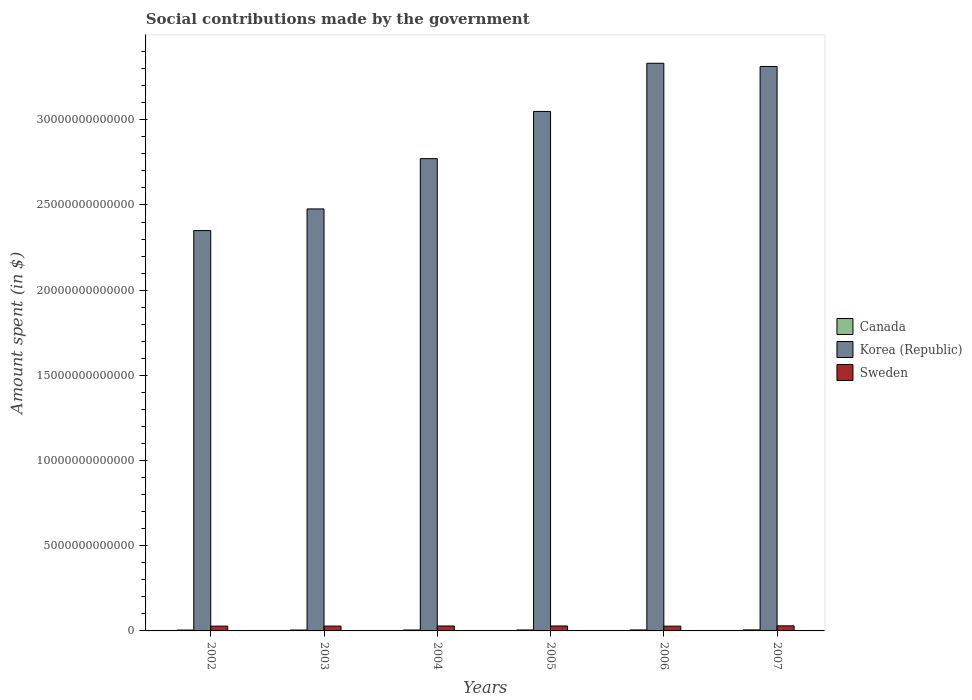How many different coloured bars are there?
Make the answer very short. 3. How many groups of bars are there?
Offer a terse response. 6. Are the number of bars on each tick of the X-axis equal?
Your answer should be compact. Yes. What is the label of the 2nd group of bars from the left?
Your response must be concise. 2003. In how many cases, is the number of bars for a given year not equal to the number of legend labels?
Your response must be concise. 0. What is the amount spent on social contributions in Sweden in 2002?
Your answer should be very brief. 2.82e+11. Across all years, what is the maximum amount spent on social contributions in Canada?
Provide a succinct answer. 6.01e+1. Across all years, what is the minimum amount spent on social contributions in Canada?
Keep it short and to the point. 5.07e+1. What is the total amount spent on social contributions in Sweden in the graph?
Ensure brevity in your answer.  1.72e+12. What is the difference between the amount spent on social contributions in Canada in 2002 and that in 2005?
Your answer should be compact. -5.92e+09. What is the difference between the amount spent on social contributions in Korea (Republic) in 2007 and the amount spent on social contributions in Sweden in 2006?
Offer a terse response. 3.29e+13. What is the average amount spent on social contributions in Korea (Republic) per year?
Provide a short and direct response. 2.88e+13. In the year 2006, what is the difference between the amount spent on social contributions in Korea (Republic) and amount spent on social contributions in Sweden?
Offer a terse response. 3.30e+13. In how many years, is the amount spent on social contributions in Canada greater than 8000000000000 $?
Your response must be concise. 0. What is the ratio of the amount spent on social contributions in Sweden in 2003 to that in 2007?
Provide a short and direct response. 0.95. What is the difference between the highest and the second highest amount spent on social contributions in Sweden?
Ensure brevity in your answer.  7.53e+09. What is the difference between the highest and the lowest amount spent on social contributions in Canada?
Ensure brevity in your answer.  9.34e+09. In how many years, is the amount spent on social contributions in Sweden greater than the average amount spent on social contributions in Sweden taken over all years?
Offer a terse response. 3. Is the sum of the amount spent on social contributions in Korea (Republic) in 2003 and 2007 greater than the maximum amount spent on social contributions in Sweden across all years?
Provide a succinct answer. Yes. What does the 2nd bar from the left in 2004 represents?
Your response must be concise. Korea (Republic). What does the 3rd bar from the right in 2007 represents?
Your response must be concise. Canada. Is it the case that in every year, the sum of the amount spent on social contributions in Sweden and amount spent on social contributions in Canada is greater than the amount spent on social contributions in Korea (Republic)?
Make the answer very short. No. How many bars are there?
Offer a very short reply. 18. Are all the bars in the graph horizontal?
Offer a very short reply. No. What is the difference between two consecutive major ticks on the Y-axis?
Your answer should be very brief. 5.00e+12. Are the values on the major ticks of Y-axis written in scientific E-notation?
Offer a terse response. No. How many legend labels are there?
Ensure brevity in your answer.  3. How are the legend labels stacked?
Provide a succinct answer. Vertical. What is the title of the graph?
Keep it short and to the point. Social contributions made by the government. Does "Benin" appear as one of the legend labels in the graph?
Offer a terse response. No. What is the label or title of the X-axis?
Provide a short and direct response. Years. What is the label or title of the Y-axis?
Offer a very short reply. Amount spent (in $). What is the Amount spent (in $) in Canada in 2002?
Ensure brevity in your answer.  5.07e+1. What is the Amount spent (in $) of Korea (Republic) in 2002?
Provide a succinct answer. 2.35e+13. What is the Amount spent (in $) of Sweden in 2002?
Offer a terse response. 2.82e+11. What is the Amount spent (in $) in Canada in 2003?
Provide a succinct answer. 5.30e+1. What is the Amount spent (in $) of Korea (Republic) in 2003?
Make the answer very short. 2.48e+13. What is the Amount spent (in $) of Sweden in 2003?
Offer a terse response. 2.84e+11. What is the Amount spent (in $) of Canada in 2004?
Offer a very short reply. 5.40e+1. What is the Amount spent (in $) in Korea (Republic) in 2004?
Offer a very short reply. 2.77e+13. What is the Amount spent (in $) of Sweden in 2004?
Your response must be concise. 2.89e+11. What is the Amount spent (in $) in Canada in 2005?
Offer a terse response. 5.67e+1. What is the Amount spent (in $) in Korea (Republic) in 2005?
Your answer should be very brief. 3.05e+13. What is the Amount spent (in $) of Sweden in 2005?
Ensure brevity in your answer.  2.91e+11. What is the Amount spent (in $) of Canada in 2006?
Ensure brevity in your answer.  5.79e+1. What is the Amount spent (in $) in Korea (Republic) in 2006?
Provide a succinct answer. 3.33e+13. What is the Amount spent (in $) in Sweden in 2006?
Give a very brief answer. 2.80e+11. What is the Amount spent (in $) in Canada in 2007?
Keep it short and to the point. 6.01e+1. What is the Amount spent (in $) in Korea (Republic) in 2007?
Your answer should be very brief. 3.31e+13. What is the Amount spent (in $) in Sweden in 2007?
Your answer should be compact. 2.98e+11. Across all years, what is the maximum Amount spent (in $) in Canada?
Offer a terse response. 6.01e+1. Across all years, what is the maximum Amount spent (in $) of Korea (Republic)?
Keep it short and to the point. 3.33e+13. Across all years, what is the maximum Amount spent (in $) in Sweden?
Provide a succinct answer. 2.98e+11. Across all years, what is the minimum Amount spent (in $) of Canada?
Provide a short and direct response. 5.07e+1. Across all years, what is the minimum Amount spent (in $) in Korea (Republic)?
Give a very brief answer. 2.35e+13. Across all years, what is the minimum Amount spent (in $) of Sweden?
Provide a succinct answer. 2.80e+11. What is the total Amount spent (in $) of Canada in the graph?
Your answer should be compact. 3.32e+11. What is the total Amount spent (in $) of Korea (Republic) in the graph?
Give a very brief answer. 1.73e+14. What is the total Amount spent (in $) of Sweden in the graph?
Your response must be concise. 1.72e+12. What is the difference between the Amount spent (in $) in Canada in 2002 and that in 2003?
Keep it short and to the point. -2.30e+09. What is the difference between the Amount spent (in $) in Korea (Republic) in 2002 and that in 2003?
Offer a terse response. -1.27e+12. What is the difference between the Amount spent (in $) of Sweden in 2002 and that in 2003?
Your answer should be compact. -2.60e+09. What is the difference between the Amount spent (in $) of Canada in 2002 and that in 2004?
Make the answer very short. -3.24e+09. What is the difference between the Amount spent (in $) of Korea (Republic) in 2002 and that in 2004?
Ensure brevity in your answer.  -4.22e+12. What is the difference between the Amount spent (in $) of Sweden in 2002 and that in 2004?
Offer a terse response. -7.92e+09. What is the difference between the Amount spent (in $) of Canada in 2002 and that in 2005?
Ensure brevity in your answer.  -5.92e+09. What is the difference between the Amount spent (in $) in Korea (Republic) in 2002 and that in 2005?
Keep it short and to the point. -6.99e+12. What is the difference between the Amount spent (in $) in Sweden in 2002 and that in 2005?
Offer a terse response. -8.98e+09. What is the difference between the Amount spent (in $) of Canada in 2002 and that in 2006?
Give a very brief answer. -7.20e+09. What is the difference between the Amount spent (in $) of Korea (Republic) in 2002 and that in 2006?
Offer a terse response. -9.82e+12. What is the difference between the Amount spent (in $) in Sweden in 2002 and that in 2006?
Your answer should be very brief. 1.43e+09. What is the difference between the Amount spent (in $) of Canada in 2002 and that in 2007?
Offer a terse response. -9.34e+09. What is the difference between the Amount spent (in $) in Korea (Republic) in 2002 and that in 2007?
Give a very brief answer. -9.63e+12. What is the difference between the Amount spent (in $) in Sweden in 2002 and that in 2007?
Provide a short and direct response. -1.65e+1. What is the difference between the Amount spent (in $) in Canada in 2003 and that in 2004?
Offer a terse response. -9.36e+08. What is the difference between the Amount spent (in $) of Korea (Republic) in 2003 and that in 2004?
Offer a very short reply. -2.95e+12. What is the difference between the Amount spent (in $) in Sweden in 2003 and that in 2004?
Your answer should be very brief. -5.32e+09. What is the difference between the Amount spent (in $) of Canada in 2003 and that in 2005?
Your response must be concise. -3.62e+09. What is the difference between the Amount spent (in $) in Korea (Republic) in 2003 and that in 2005?
Ensure brevity in your answer.  -5.72e+12. What is the difference between the Amount spent (in $) of Sweden in 2003 and that in 2005?
Keep it short and to the point. -6.39e+09. What is the difference between the Amount spent (in $) of Canada in 2003 and that in 2006?
Give a very brief answer. -4.90e+09. What is the difference between the Amount spent (in $) in Korea (Republic) in 2003 and that in 2006?
Make the answer very short. -8.55e+12. What is the difference between the Amount spent (in $) of Sweden in 2003 and that in 2006?
Provide a short and direct response. 4.03e+09. What is the difference between the Amount spent (in $) in Canada in 2003 and that in 2007?
Make the answer very short. -7.04e+09. What is the difference between the Amount spent (in $) of Korea (Republic) in 2003 and that in 2007?
Provide a short and direct response. -8.36e+12. What is the difference between the Amount spent (in $) of Sweden in 2003 and that in 2007?
Offer a very short reply. -1.39e+1. What is the difference between the Amount spent (in $) in Canada in 2004 and that in 2005?
Offer a very short reply. -2.69e+09. What is the difference between the Amount spent (in $) of Korea (Republic) in 2004 and that in 2005?
Your response must be concise. -2.77e+12. What is the difference between the Amount spent (in $) in Sweden in 2004 and that in 2005?
Offer a terse response. -1.06e+09. What is the difference between the Amount spent (in $) in Canada in 2004 and that in 2006?
Your answer should be very brief. -3.96e+09. What is the difference between the Amount spent (in $) of Korea (Republic) in 2004 and that in 2006?
Make the answer very short. -5.60e+12. What is the difference between the Amount spent (in $) of Sweden in 2004 and that in 2006?
Your response must be concise. 9.35e+09. What is the difference between the Amount spent (in $) in Canada in 2004 and that in 2007?
Provide a succinct answer. -6.10e+09. What is the difference between the Amount spent (in $) in Korea (Republic) in 2004 and that in 2007?
Ensure brevity in your answer.  -5.41e+12. What is the difference between the Amount spent (in $) of Sweden in 2004 and that in 2007?
Your response must be concise. -8.59e+09. What is the difference between the Amount spent (in $) of Canada in 2005 and that in 2006?
Keep it short and to the point. -1.27e+09. What is the difference between the Amount spent (in $) in Korea (Republic) in 2005 and that in 2006?
Your response must be concise. -2.83e+12. What is the difference between the Amount spent (in $) in Sweden in 2005 and that in 2006?
Offer a terse response. 1.04e+1. What is the difference between the Amount spent (in $) of Canada in 2005 and that in 2007?
Your answer should be compact. -3.41e+09. What is the difference between the Amount spent (in $) of Korea (Republic) in 2005 and that in 2007?
Give a very brief answer. -2.64e+12. What is the difference between the Amount spent (in $) of Sweden in 2005 and that in 2007?
Make the answer very short. -7.53e+09. What is the difference between the Amount spent (in $) in Canada in 2006 and that in 2007?
Provide a short and direct response. -2.14e+09. What is the difference between the Amount spent (in $) of Korea (Republic) in 2006 and that in 2007?
Provide a succinct answer. 1.88e+11. What is the difference between the Amount spent (in $) of Sweden in 2006 and that in 2007?
Your answer should be very brief. -1.79e+1. What is the difference between the Amount spent (in $) of Canada in 2002 and the Amount spent (in $) of Korea (Republic) in 2003?
Your response must be concise. -2.47e+13. What is the difference between the Amount spent (in $) in Canada in 2002 and the Amount spent (in $) in Sweden in 2003?
Provide a succinct answer. -2.33e+11. What is the difference between the Amount spent (in $) in Korea (Republic) in 2002 and the Amount spent (in $) in Sweden in 2003?
Provide a succinct answer. 2.32e+13. What is the difference between the Amount spent (in $) in Canada in 2002 and the Amount spent (in $) in Korea (Republic) in 2004?
Your response must be concise. -2.77e+13. What is the difference between the Amount spent (in $) of Canada in 2002 and the Amount spent (in $) of Sweden in 2004?
Give a very brief answer. -2.39e+11. What is the difference between the Amount spent (in $) in Korea (Republic) in 2002 and the Amount spent (in $) in Sweden in 2004?
Your answer should be compact. 2.32e+13. What is the difference between the Amount spent (in $) in Canada in 2002 and the Amount spent (in $) in Korea (Republic) in 2005?
Ensure brevity in your answer.  -3.04e+13. What is the difference between the Amount spent (in $) in Canada in 2002 and the Amount spent (in $) in Sweden in 2005?
Your response must be concise. -2.40e+11. What is the difference between the Amount spent (in $) in Korea (Republic) in 2002 and the Amount spent (in $) in Sweden in 2005?
Your response must be concise. 2.32e+13. What is the difference between the Amount spent (in $) of Canada in 2002 and the Amount spent (in $) of Korea (Republic) in 2006?
Your answer should be compact. -3.33e+13. What is the difference between the Amount spent (in $) in Canada in 2002 and the Amount spent (in $) in Sweden in 2006?
Your answer should be very brief. -2.29e+11. What is the difference between the Amount spent (in $) in Korea (Republic) in 2002 and the Amount spent (in $) in Sweden in 2006?
Provide a succinct answer. 2.32e+13. What is the difference between the Amount spent (in $) of Canada in 2002 and the Amount spent (in $) of Korea (Republic) in 2007?
Your response must be concise. -3.31e+13. What is the difference between the Amount spent (in $) of Canada in 2002 and the Amount spent (in $) of Sweden in 2007?
Your answer should be compact. -2.47e+11. What is the difference between the Amount spent (in $) of Korea (Republic) in 2002 and the Amount spent (in $) of Sweden in 2007?
Keep it short and to the point. 2.32e+13. What is the difference between the Amount spent (in $) in Canada in 2003 and the Amount spent (in $) in Korea (Republic) in 2004?
Give a very brief answer. -2.77e+13. What is the difference between the Amount spent (in $) in Canada in 2003 and the Amount spent (in $) in Sweden in 2004?
Your answer should be very brief. -2.36e+11. What is the difference between the Amount spent (in $) in Korea (Republic) in 2003 and the Amount spent (in $) in Sweden in 2004?
Make the answer very short. 2.45e+13. What is the difference between the Amount spent (in $) in Canada in 2003 and the Amount spent (in $) in Korea (Republic) in 2005?
Provide a succinct answer. -3.04e+13. What is the difference between the Amount spent (in $) of Canada in 2003 and the Amount spent (in $) of Sweden in 2005?
Provide a short and direct response. -2.38e+11. What is the difference between the Amount spent (in $) of Korea (Republic) in 2003 and the Amount spent (in $) of Sweden in 2005?
Your answer should be very brief. 2.45e+13. What is the difference between the Amount spent (in $) of Canada in 2003 and the Amount spent (in $) of Korea (Republic) in 2006?
Make the answer very short. -3.33e+13. What is the difference between the Amount spent (in $) of Canada in 2003 and the Amount spent (in $) of Sweden in 2006?
Your answer should be very brief. -2.27e+11. What is the difference between the Amount spent (in $) in Korea (Republic) in 2003 and the Amount spent (in $) in Sweden in 2006?
Ensure brevity in your answer.  2.45e+13. What is the difference between the Amount spent (in $) of Canada in 2003 and the Amount spent (in $) of Korea (Republic) in 2007?
Make the answer very short. -3.31e+13. What is the difference between the Amount spent (in $) in Canada in 2003 and the Amount spent (in $) in Sweden in 2007?
Your answer should be very brief. -2.45e+11. What is the difference between the Amount spent (in $) of Korea (Republic) in 2003 and the Amount spent (in $) of Sweden in 2007?
Keep it short and to the point. 2.45e+13. What is the difference between the Amount spent (in $) in Canada in 2004 and the Amount spent (in $) in Korea (Republic) in 2005?
Your response must be concise. -3.04e+13. What is the difference between the Amount spent (in $) of Canada in 2004 and the Amount spent (in $) of Sweden in 2005?
Give a very brief answer. -2.37e+11. What is the difference between the Amount spent (in $) of Korea (Republic) in 2004 and the Amount spent (in $) of Sweden in 2005?
Ensure brevity in your answer.  2.74e+13. What is the difference between the Amount spent (in $) in Canada in 2004 and the Amount spent (in $) in Korea (Republic) in 2006?
Your response must be concise. -3.33e+13. What is the difference between the Amount spent (in $) in Canada in 2004 and the Amount spent (in $) in Sweden in 2006?
Your answer should be very brief. -2.26e+11. What is the difference between the Amount spent (in $) of Korea (Republic) in 2004 and the Amount spent (in $) of Sweden in 2006?
Provide a succinct answer. 2.74e+13. What is the difference between the Amount spent (in $) in Canada in 2004 and the Amount spent (in $) in Korea (Republic) in 2007?
Provide a succinct answer. -3.31e+13. What is the difference between the Amount spent (in $) of Canada in 2004 and the Amount spent (in $) of Sweden in 2007?
Offer a terse response. -2.44e+11. What is the difference between the Amount spent (in $) in Korea (Republic) in 2004 and the Amount spent (in $) in Sweden in 2007?
Keep it short and to the point. 2.74e+13. What is the difference between the Amount spent (in $) in Canada in 2005 and the Amount spent (in $) in Korea (Republic) in 2006?
Your answer should be very brief. -3.33e+13. What is the difference between the Amount spent (in $) in Canada in 2005 and the Amount spent (in $) in Sweden in 2006?
Provide a short and direct response. -2.23e+11. What is the difference between the Amount spent (in $) in Korea (Republic) in 2005 and the Amount spent (in $) in Sweden in 2006?
Provide a succinct answer. 3.02e+13. What is the difference between the Amount spent (in $) in Canada in 2005 and the Amount spent (in $) in Korea (Republic) in 2007?
Your response must be concise. -3.31e+13. What is the difference between the Amount spent (in $) of Canada in 2005 and the Amount spent (in $) of Sweden in 2007?
Provide a short and direct response. -2.41e+11. What is the difference between the Amount spent (in $) in Korea (Republic) in 2005 and the Amount spent (in $) in Sweden in 2007?
Give a very brief answer. 3.02e+13. What is the difference between the Amount spent (in $) of Canada in 2006 and the Amount spent (in $) of Korea (Republic) in 2007?
Keep it short and to the point. -3.31e+13. What is the difference between the Amount spent (in $) in Canada in 2006 and the Amount spent (in $) in Sweden in 2007?
Provide a succinct answer. -2.40e+11. What is the difference between the Amount spent (in $) in Korea (Republic) in 2006 and the Amount spent (in $) in Sweden in 2007?
Give a very brief answer. 3.30e+13. What is the average Amount spent (in $) of Canada per year?
Provide a short and direct response. 5.54e+1. What is the average Amount spent (in $) of Korea (Republic) per year?
Provide a succinct answer. 2.88e+13. What is the average Amount spent (in $) in Sweden per year?
Make the answer very short. 2.87e+11. In the year 2002, what is the difference between the Amount spent (in $) in Canada and Amount spent (in $) in Korea (Republic)?
Your answer should be compact. -2.34e+13. In the year 2002, what is the difference between the Amount spent (in $) in Canada and Amount spent (in $) in Sweden?
Offer a very short reply. -2.31e+11. In the year 2002, what is the difference between the Amount spent (in $) of Korea (Republic) and Amount spent (in $) of Sweden?
Offer a terse response. 2.32e+13. In the year 2003, what is the difference between the Amount spent (in $) of Canada and Amount spent (in $) of Korea (Republic)?
Your answer should be very brief. -2.47e+13. In the year 2003, what is the difference between the Amount spent (in $) of Canada and Amount spent (in $) of Sweden?
Offer a terse response. -2.31e+11. In the year 2003, what is the difference between the Amount spent (in $) of Korea (Republic) and Amount spent (in $) of Sweden?
Your answer should be very brief. 2.45e+13. In the year 2004, what is the difference between the Amount spent (in $) of Canada and Amount spent (in $) of Korea (Republic)?
Offer a very short reply. -2.77e+13. In the year 2004, what is the difference between the Amount spent (in $) in Canada and Amount spent (in $) in Sweden?
Offer a terse response. -2.36e+11. In the year 2004, what is the difference between the Amount spent (in $) of Korea (Republic) and Amount spent (in $) of Sweden?
Keep it short and to the point. 2.74e+13. In the year 2005, what is the difference between the Amount spent (in $) of Canada and Amount spent (in $) of Korea (Republic)?
Give a very brief answer. -3.04e+13. In the year 2005, what is the difference between the Amount spent (in $) of Canada and Amount spent (in $) of Sweden?
Your answer should be compact. -2.34e+11. In the year 2005, what is the difference between the Amount spent (in $) of Korea (Republic) and Amount spent (in $) of Sweden?
Give a very brief answer. 3.02e+13. In the year 2006, what is the difference between the Amount spent (in $) of Canada and Amount spent (in $) of Korea (Republic)?
Provide a short and direct response. -3.33e+13. In the year 2006, what is the difference between the Amount spent (in $) of Canada and Amount spent (in $) of Sweden?
Ensure brevity in your answer.  -2.22e+11. In the year 2006, what is the difference between the Amount spent (in $) of Korea (Republic) and Amount spent (in $) of Sweden?
Keep it short and to the point. 3.30e+13. In the year 2007, what is the difference between the Amount spent (in $) in Canada and Amount spent (in $) in Korea (Republic)?
Your answer should be compact. -3.31e+13. In the year 2007, what is the difference between the Amount spent (in $) in Canada and Amount spent (in $) in Sweden?
Your answer should be compact. -2.38e+11. In the year 2007, what is the difference between the Amount spent (in $) in Korea (Republic) and Amount spent (in $) in Sweden?
Offer a terse response. 3.28e+13. What is the ratio of the Amount spent (in $) of Canada in 2002 to that in 2003?
Your answer should be compact. 0.96. What is the ratio of the Amount spent (in $) of Korea (Republic) in 2002 to that in 2003?
Provide a short and direct response. 0.95. What is the ratio of the Amount spent (in $) in Sweden in 2002 to that in 2003?
Give a very brief answer. 0.99. What is the ratio of the Amount spent (in $) in Canada in 2002 to that in 2004?
Offer a terse response. 0.94. What is the ratio of the Amount spent (in $) in Korea (Republic) in 2002 to that in 2004?
Provide a short and direct response. 0.85. What is the ratio of the Amount spent (in $) in Sweden in 2002 to that in 2004?
Offer a terse response. 0.97. What is the ratio of the Amount spent (in $) in Canada in 2002 to that in 2005?
Keep it short and to the point. 0.9. What is the ratio of the Amount spent (in $) in Korea (Republic) in 2002 to that in 2005?
Your answer should be very brief. 0.77. What is the ratio of the Amount spent (in $) in Sweden in 2002 to that in 2005?
Your answer should be very brief. 0.97. What is the ratio of the Amount spent (in $) in Canada in 2002 to that in 2006?
Offer a terse response. 0.88. What is the ratio of the Amount spent (in $) in Korea (Republic) in 2002 to that in 2006?
Give a very brief answer. 0.71. What is the ratio of the Amount spent (in $) in Sweden in 2002 to that in 2006?
Your answer should be compact. 1.01. What is the ratio of the Amount spent (in $) in Canada in 2002 to that in 2007?
Provide a short and direct response. 0.84. What is the ratio of the Amount spent (in $) in Korea (Republic) in 2002 to that in 2007?
Your answer should be very brief. 0.71. What is the ratio of the Amount spent (in $) in Sweden in 2002 to that in 2007?
Your answer should be very brief. 0.94. What is the ratio of the Amount spent (in $) of Canada in 2003 to that in 2004?
Your answer should be very brief. 0.98. What is the ratio of the Amount spent (in $) of Korea (Republic) in 2003 to that in 2004?
Your answer should be very brief. 0.89. What is the ratio of the Amount spent (in $) of Sweden in 2003 to that in 2004?
Provide a short and direct response. 0.98. What is the ratio of the Amount spent (in $) of Canada in 2003 to that in 2005?
Ensure brevity in your answer.  0.94. What is the ratio of the Amount spent (in $) of Korea (Republic) in 2003 to that in 2005?
Provide a succinct answer. 0.81. What is the ratio of the Amount spent (in $) in Canada in 2003 to that in 2006?
Your response must be concise. 0.92. What is the ratio of the Amount spent (in $) of Korea (Republic) in 2003 to that in 2006?
Ensure brevity in your answer.  0.74. What is the ratio of the Amount spent (in $) of Sweden in 2003 to that in 2006?
Provide a short and direct response. 1.01. What is the ratio of the Amount spent (in $) in Canada in 2003 to that in 2007?
Offer a very short reply. 0.88. What is the ratio of the Amount spent (in $) of Korea (Republic) in 2003 to that in 2007?
Provide a short and direct response. 0.75. What is the ratio of the Amount spent (in $) in Sweden in 2003 to that in 2007?
Provide a succinct answer. 0.95. What is the ratio of the Amount spent (in $) in Canada in 2004 to that in 2005?
Give a very brief answer. 0.95. What is the ratio of the Amount spent (in $) in Korea (Republic) in 2004 to that in 2005?
Your answer should be compact. 0.91. What is the ratio of the Amount spent (in $) of Sweden in 2004 to that in 2005?
Your answer should be very brief. 1. What is the ratio of the Amount spent (in $) of Canada in 2004 to that in 2006?
Make the answer very short. 0.93. What is the ratio of the Amount spent (in $) in Korea (Republic) in 2004 to that in 2006?
Offer a very short reply. 0.83. What is the ratio of the Amount spent (in $) of Sweden in 2004 to that in 2006?
Keep it short and to the point. 1.03. What is the ratio of the Amount spent (in $) of Canada in 2004 to that in 2007?
Provide a short and direct response. 0.9. What is the ratio of the Amount spent (in $) in Korea (Republic) in 2004 to that in 2007?
Offer a very short reply. 0.84. What is the ratio of the Amount spent (in $) of Sweden in 2004 to that in 2007?
Make the answer very short. 0.97. What is the ratio of the Amount spent (in $) of Canada in 2005 to that in 2006?
Offer a very short reply. 0.98. What is the ratio of the Amount spent (in $) in Korea (Republic) in 2005 to that in 2006?
Provide a short and direct response. 0.92. What is the ratio of the Amount spent (in $) of Sweden in 2005 to that in 2006?
Your answer should be very brief. 1.04. What is the ratio of the Amount spent (in $) in Canada in 2005 to that in 2007?
Your response must be concise. 0.94. What is the ratio of the Amount spent (in $) of Korea (Republic) in 2005 to that in 2007?
Keep it short and to the point. 0.92. What is the ratio of the Amount spent (in $) in Sweden in 2005 to that in 2007?
Your answer should be compact. 0.97. What is the ratio of the Amount spent (in $) in Canada in 2006 to that in 2007?
Keep it short and to the point. 0.96. What is the ratio of the Amount spent (in $) in Sweden in 2006 to that in 2007?
Offer a terse response. 0.94. What is the difference between the highest and the second highest Amount spent (in $) in Canada?
Offer a terse response. 2.14e+09. What is the difference between the highest and the second highest Amount spent (in $) of Korea (Republic)?
Your response must be concise. 1.88e+11. What is the difference between the highest and the second highest Amount spent (in $) of Sweden?
Your answer should be compact. 7.53e+09. What is the difference between the highest and the lowest Amount spent (in $) in Canada?
Your response must be concise. 9.34e+09. What is the difference between the highest and the lowest Amount spent (in $) of Korea (Republic)?
Your answer should be very brief. 9.82e+12. What is the difference between the highest and the lowest Amount spent (in $) of Sweden?
Offer a very short reply. 1.79e+1. 